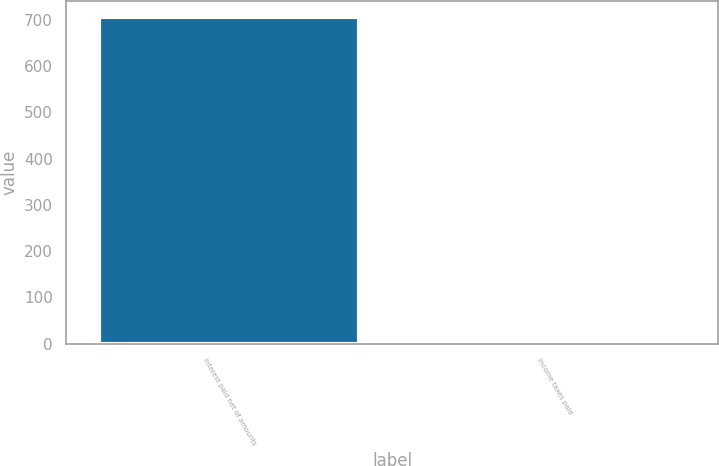Convert chart to OTSL. <chart><loc_0><loc_0><loc_500><loc_500><bar_chart><fcel>Interest paid net of amounts<fcel>Income taxes paid<nl><fcel>706<fcel>7<nl></chart> 